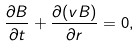<formula> <loc_0><loc_0><loc_500><loc_500>\frac { \partial B } { \partial t } + \frac { \partial ( v B ) } { \partial r } = 0 ,</formula> 